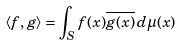<formula> <loc_0><loc_0><loc_500><loc_500>\langle f , g \rangle = \int _ { S } f ( x ) { \overline { g ( x ) } } \, d \mu ( x )</formula> 